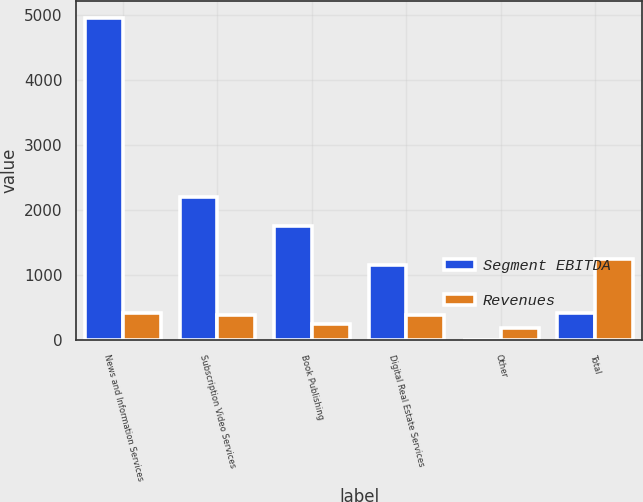<chart> <loc_0><loc_0><loc_500><loc_500><stacked_bar_chart><ecel><fcel>News and Information Services<fcel>Subscription Video Services<fcel>Book Publishing<fcel>Digital Real Estate Services<fcel>Other<fcel>Total<nl><fcel>Segment EBITDA<fcel>4956<fcel>2202<fcel>1754<fcel>1159<fcel>3<fcel>417<nl><fcel>Revenues<fcel>417<fcel>380<fcel>253<fcel>384<fcel>190<fcel>1244<nl></chart> 